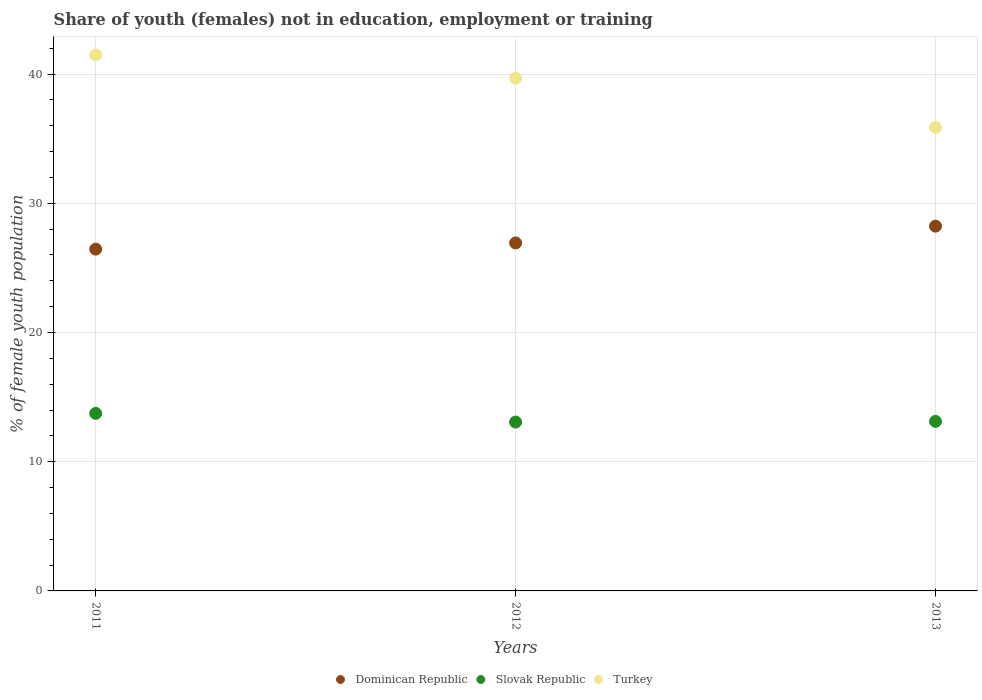What is the percentage of unemployed female population in in Dominican Republic in 2012?
Your answer should be compact. 26.93. Across all years, what is the maximum percentage of unemployed female population in in Turkey?
Make the answer very short. 41.48. Across all years, what is the minimum percentage of unemployed female population in in Slovak Republic?
Keep it short and to the point. 13.07. What is the total percentage of unemployed female population in in Turkey in the graph?
Give a very brief answer. 117.02. What is the difference between the percentage of unemployed female population in in Slovak Republic in 2011 and that in 2013?
Offer a terse response. 0.62. What is the difference between the percentage of unemployed female population in in Dominican Republic in 2011 and the percentage of unemployed female population in in Slovak Republic in 2013?
Make the answer very short. 13.33. What is the average percentage of unemployed female population in in Slovak Republic per year?
Provide a succinct answer. 13.31. In the year 2013, what is the difference between the percentage of unemployed female population in in Slovak Republic and percentage of unemployed female population in in Turkey?
Your response must be concise. -22.75. What is the ratio of the percentage of unemployed female population in in Turkey in 2012 to that in 2013?
Make the answer very short. 1.11. Is the percentage of unemployed female population in in Slovak Republic in 2011 less than that in 2012?
Keep it short and to the point. No. What is the difference between the highest and the second highest percentage of unemployed female population in in Turkey?
Provide a short and direct response. 1.81. What is the difference between the highest and the lowest percentage of unemployed female population in in Slovak Republic?
Your response must be concise. 0.67. In how many years, is the percentage of unemployed female population in in Turkey greater than the average percentage of unemployed female population in in Turkey taken over all years?
Keep it short and to the point. 2. Is the sum of the percentage of unemployed female population in in Turkey in 2012 and 2013 greater than the maximum percentage of unemployed female population in in Slovak Republic across all years?
Provide a short and direct response. Yes. Is it the case that in every year, the sum of the percentage of unemployed female population in in Dominican Republic and percentage of unemployed female population in in Turkey  is greater than the percentage of unemployed female population in in Slovak Republic?
Your answer should be very brief. Yes. Is the percentage of unemployed female population in in Slovak Republic strictly greater than the percentage of unemployed female population in in Turkey over the years?
Ensure brevity in your answer.  No. How many dotlines are there?
Offer a terse response. 3. How many years are there in the graph?
Your answer should be very brief. 3. Are the values on the major ticks of Y-axis written in scientific E-notation?
Your answer should be compact. No. How many legend labels are there?
Your answer should be very brief. 3. What is the title of the graph?
Your answer should be very brief. Share of youth (females) not in education, employment or training. What is the label or title of the Y-axis?
Make the answer very short. % of female youth population. What is the % of female youth population in Dominican Republic in 2011?
Your answer should be very brief. 26.45. What is the % of female youth population of Slovak Republic in 2011?
Give a very brief answer. 13.74. What is the % of female youth population in Turkey in 2011?
Your answer should be compact. 41.48. What is the % of female youth population in Dominican Republic in 2012?
Your answer should be compact. 26.93. What is the % of female youth population in Slovak Republic in 2012?
Give a very brief answer. 13.07. What is the % of female youth population of Turkey in 2012?
Your answer should be very brief. 39.67. What is the % of female youth population in Dominican Republic in 2013?
Keep it short and to the point. 28.23. What is the % of female youth population of Slovak Republic in 2013?
Your answer should be compact. 13.12. What is the % of female youth population of Turkey in 2013?
Your answer should be compact. 35.87. Across all years, what is the maximum % of female youth population in Dominican Republic?
Give a very brief answer. 28.23. Across all years, what is the maximum % of female youth population of Slovak Republic?
Make the answer very short. 13.74. Across all years, what is the maximum % of female youth population in Turkey?
Offer a terse response. 41.48. Across all years, what is the minimum % of female youth population of Dominican Republic?
Offer a terse response. 26.45. Across all years, what is the minimum % of female youth population in Slovak Republic?
Provide a succinct answer. 13.07. Across all years, what is the minimum % of female youth population of Turkey?
Your response must be concise. 35.87. What is the total % of female youth population in Dominican Republic in the graph?
Ensure brevity in your answer.  81.61. What is the total % of female youth population in Slovak Republic in the graph?
Provide a succinct answer. 39.93. What is the total % of female youth population of Turkey in the graph?
Give a very brief answer. 117.02. What is the difference between the % of female youth population of Dominican Republic in 2011 and that in 2012?
Your answer should be very brief. -0.48. What is the difference between the % of female youth population of Slovak Republic in 2011 and that in 2012?
Make the answer very short. 0.67. What is the difference between the % of female youth population of Turkey in 2011 and that in 2012?
Offer a terse response. 1.81. What is the difference between the % of female youth population of Dominican Republic in 2011 and that in 2013?
Your answer should be very brief. -1.78. What is the difference between the % of female youth population in Slovak Republic in 2011 and that in 2013?
Make the answer very short. 0.62. What is the difference between the % of female youth population of Turkey in 2011 and that in 2013?
Give a very brief answer. 5.61. What is the difference between the % of female youth population of Slovak Republic in 2012 and that in 2013?
Make the answer very short. -0.05. What is the difference between the % of female youth population of Dominican Republic in 2011 and the % of female youth population of Slovak Republic in 2012?
Provide a succinct answer. 13.38. What is the difference between the % of female youth population in Dominican Republic in 2011 and the % of female youth population in Turkey in 2012?
Make the answer very short. -13.22. What is the difference between the % of female youth population of Slovak Republic in 2011 and the % of female youth population of Turkey in 2012?
Provide a short and direct response. -25.93. What is the difference between the % of female youth population of Dominican Republic in 2011 and the % of female youth population of Slovak Republic in 2013?
Make the answer very short. 13.33. What is the difference between the % of female youth population of Dominican Republic in 2011 and the % of female youth population of Turkey in 2013?
Offer a terse response. -9.42. What is the difference between the % of female youth population of Slovak Republic in 2011 and the % of female youth population of Turkey in 2013?
Provide a short and direct response. -22.13. What is the difference between the % of female youth population of Dominican Republic in 2012 and the % of female youth population of Slovak Republic in 2013?
Keep it short and to the point. 13.81. What is the difference between the % of female youth population of Dominican Republic in 2012 and the % of female youth population of Turkey in 2013?
Provide a succinct answer. -8.94. What is the difference between the % of female youth population of Slovak Republic in 2012 and the % of female youth population of Turkey in 2013?
Keep it short and to the point. -22.8. What is the average % of female youth population in Dominican Republic per year?
Your answer should be compact. 27.2. What is the average % of female youth population of Slovak Republic per year?
Give a very brief answer. 13.31. What is the average % of female youth population in Turkey per year?
Offer a very short reply. 39.01. In the year 2011, what is the difference between the % of female youth population in Dominican Republic and % of female youth population in Slovak Republic?
Keep it short and to the point. 12.71. In the year 2011, what is the difference between the % of female youth population of Dominican Republic and % of female youth population of Turkey?
Keep it short and to the point. -15.03. In the year 2011, what is the difference between the % of female youth population of Slovak Republic and % of female youth population of Turkey?
Your answer should be compact. -27.74. In the year 2012, what is the difference between the % of female youth population of Dominican Republic and % of female youth population of Slovak Republic?
Offer a terse response. 13.86. In the year 2012, what is the difference between the % of female youth population of Dominican Republic and % of female youth population of Turkey?
Make the answer very short. -12.74. In the year 2012, what is the difference between the % of female youth population in Slovak Republic and % of female youth population in Turkey?
Offer a terse response. -26.6. In the year 2013, what is the difference between the % of female youth population of Dominican Republic and % of female youth population of Slovak Republic?
Ensure brevity in your answer.  15.11. In the year 2013, what is the difference between the % of female youth population in Dominican Republic and % of female youth population in Turkey?
Ensure brevity in your answer.  -7.64. In the year 2013, what is the difference between the % of female youth population of Slovak Republic and % of female youth population of Turkey?
Your answer should be compact. -22.75. What is the ratio of the % of female youth population of Dominican Republic in 2011 to that in 2012?
Your answer should be very brief. 0.98. What is the ratio of the % of female youth population in Slovak Republic in 2011 to that in 2012?
Give a very brief answer. 1.05. What is the ratio of the % of female youth population of Turkey in 2011 to that in 2012?
Provide a short and direct response. 1.05. What is the ratio of the % of female youth population of Dominican Republic in 2011 to that in 2013?
Keep it short and to the point. 0.94. What is the ratio of the % of female youth population of Slovak Republic in 2011 to that in 2013?
Ensure brevity in your answer.  1.05. What is the ratio of the % of female youth population in Turkey in 2011 to that in 2013?
Offer a terse response. 1.16. What is the ratio of the % of female youth population in Dominican Republic in 2012 to that in 2013?
Make the answer very short. 0.95. What is the ratio of the % of female youth population of Turkey in 2012 to that in 2013?
Provide a short and direct response. 1.11. What is the difference between the highest and the second highest % of female youth population of Slovak Republic?
Offer a very short reply. 0.62. What is the difference between the highest and the second highest % of female youth population in Turkey?
Give a very brief answer. 1.81. What is the difference between the highest and the lowest % of female youth population in Dominican Republic?
Your answer should be very brief. 1.78. What is the difference between the highest and the lowest % of female youth population of Slovak Republic?
Provide a succinct answer. 0.67. What is the difference between the highest and the lowest % of female youth population of Turkey?
Your answer should be very brief. 5.61. 